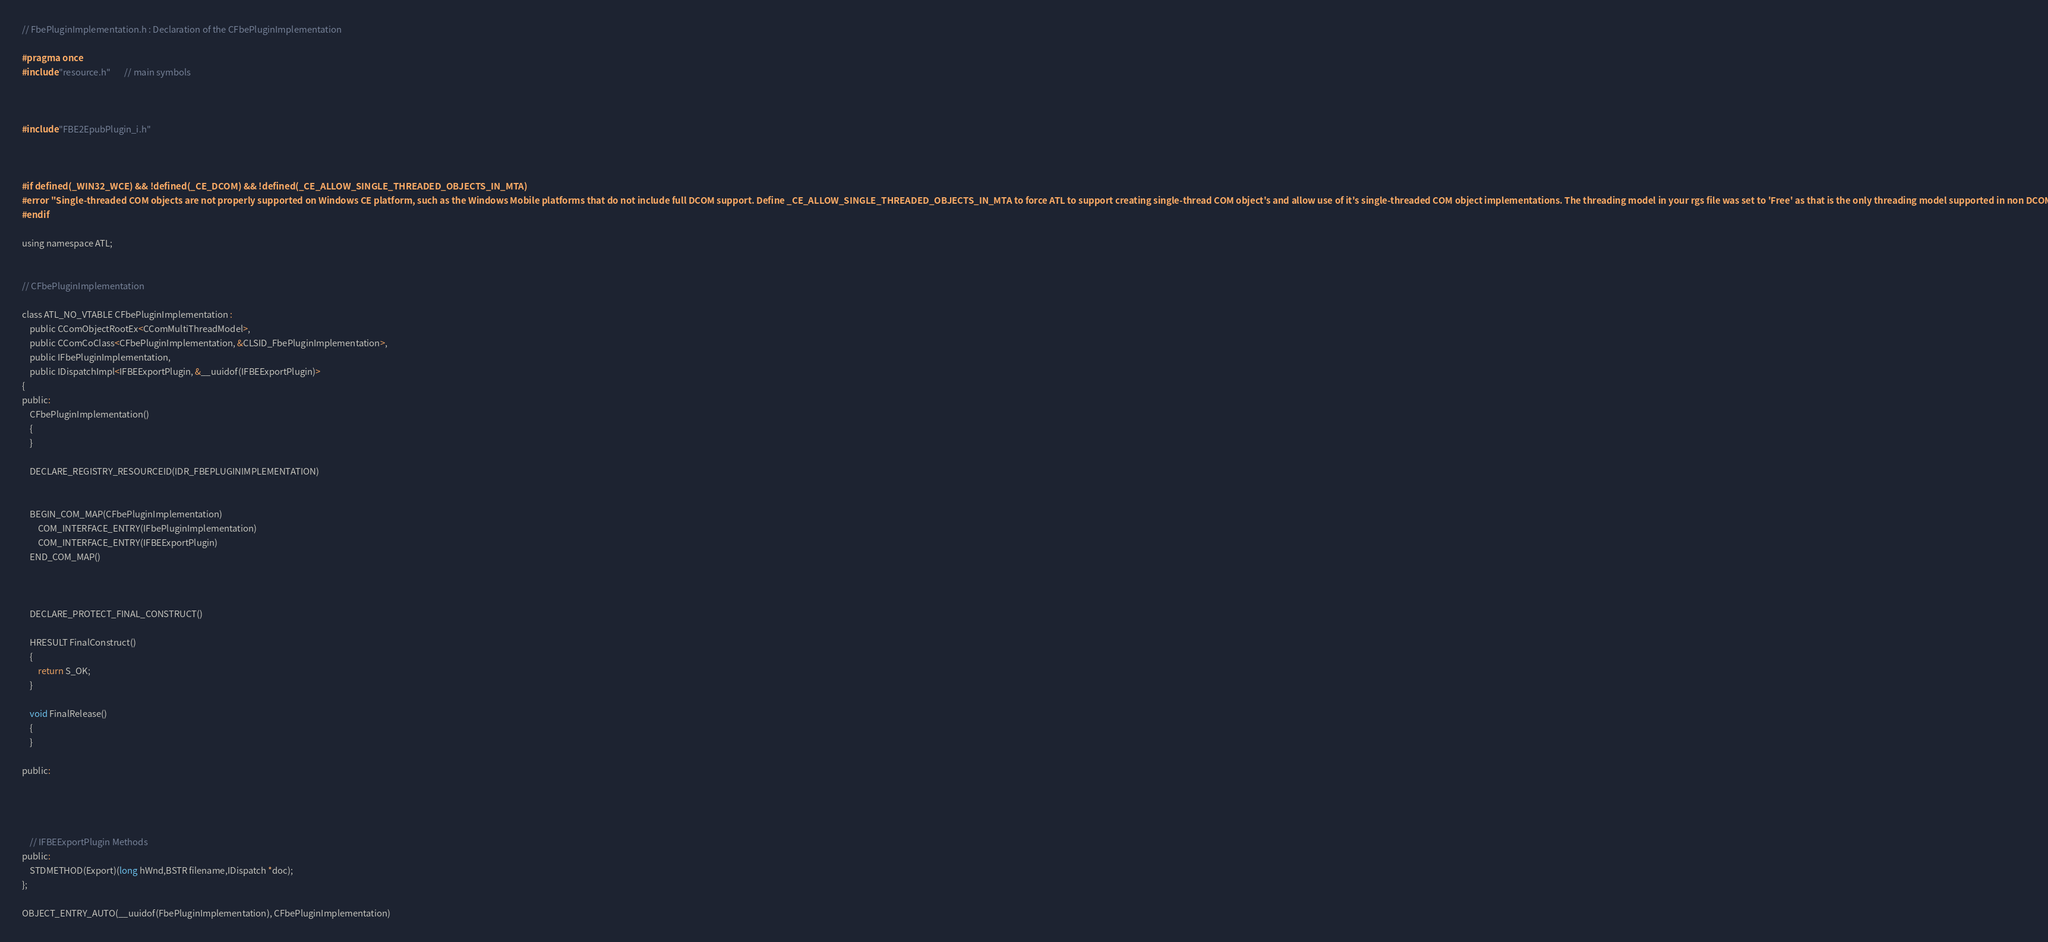Convert code to text. <code><loc_0><loc_0><loc_500><loc_500><_C_>// FbePluginImplementation.h : Declaration of the CFbePluginImplementation

#pragma once
#include "resource.h"       // main symbols



#include "FBE2EpubPlugin_i.h"



#if defined(_WIN32_WCE) && !defined(_CE_DCOM) && !defined(_CE_ALLOW_SINGLE_THREADED_OBJECTS_IN_MTA)
#error "Single-threaded COM objects are not properly supported on Windows CE platform, such as the Windows Mobile platforms that do not include full DCOM support. Define _CE_ALLOW_SINGLE_THREADED_OBJECTS_IN_MTA to force ATL to support creating single-thread COM object's and allow use of it's single-threaded COM object implementations. The threading model in your rgs file was set to 'Free' as that is the only threading model supported in non DCOM Windows CE platforms."
#endif

using namespace ATL;


// CFbePluginImplementation

class ATL_NO_VTABLE CFbePluginImplementation :
	public CComObjectRootEx<CComMultiThreadModel>,
	public CComCoClass<CFbePluginImplementation, &CLSID_FbePluginImplementation>,
	public IFbePluginImplementation,
	public IDispatchImpl<IFBEExportPlugin, &__uuidof(IFBEExportPlugin)>
{
public:
	CFbePluginImplementation()
	{
	}

	DECLARE_REGISTRY_RESOURCEID(IDR_FBEPLUGINIMPLEMENTATION)


	BEGIN_COM_MAP(CFbePluginImplementation)
		COM_INTERFACE_ENTRY(IFbePluginImplementation)
		COM_INTERFACE_ENTRY(IFBEExportPlugin)
	END_COM_MAP()



	DECLARE_PROTECT_FINAL_CONSTRUCT()

	HRESULT FinalConstruct()
	{
		return S_OK;
	}

	void FinalRelease()
	{
	}

public:




	// IFBEExportPlugin Methods
public:
	STDMETHOD(Export)(long hWnd,BSTR filename,IDispatch *doc);
};

OBJECT_ENTRY_AUTO(__uuidof(FbePluginImplementation), CFbePluginImplementation)
</code> 